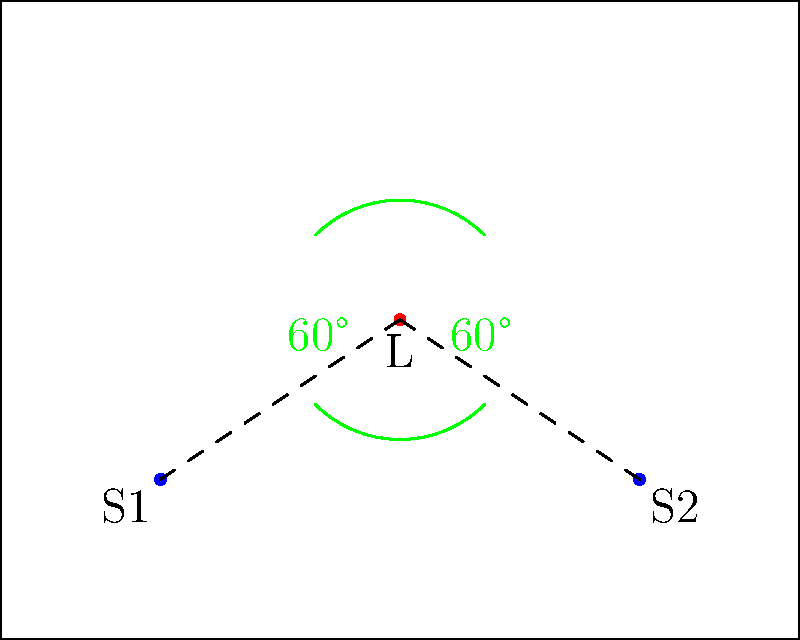In the given room layout for optimal speaker placement, what is the ideal angle between the two speakers from the listener's position, and how far should the speakers be placed from the front wall? To determine the optimal placement of speakers in a room using geometric principles, we follow these steps:

1. Listener position: The listener (L) is typically placed at the center of the room's width and about 2/3 of the room's length from the front wall.

2. Speaker angle: The ideal angle between the two speakers from the listener's position is 60° on each side, forming an equilateral triangle. This creates a total angle of 120° between the speakers.

3. Speaker distance: The speakers (S1 and S2) should be placed at an equal distance from the listener, forming the base of the equilateral triangle.

4. Front wall placement: For optimal sound reflection and to minimize early reflections, speakers should be placed about 1/3 of the room's length from the front wall.

5. Side wall placement: Speakers should be placed at least 2-3 feet away from side walls to reduce unwanted reflections.

In the diagram:
- The green arcs represent the 60° angles from the listener to each speaker.
- The dashed lines show the equal distances from the listener to each speaker.
- The speakers are positioned about 1/3 of the room's length from the front wall.

This arrangement ensures:
- A wide, balanced stereo image
- Minimal early reflections from walls
- Optimal sound quality at the listening position
Answer: 120° angle between speakers; 1/3 room length from front wall 